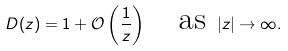<formula> <loc_0><loc_0><loc_500><loc_500>D ( z ) = 1 + \mathcal { O } \left ( \frac { 1 } { z } \right ) \quad \text {as } | z | \to \infty .</formula> 